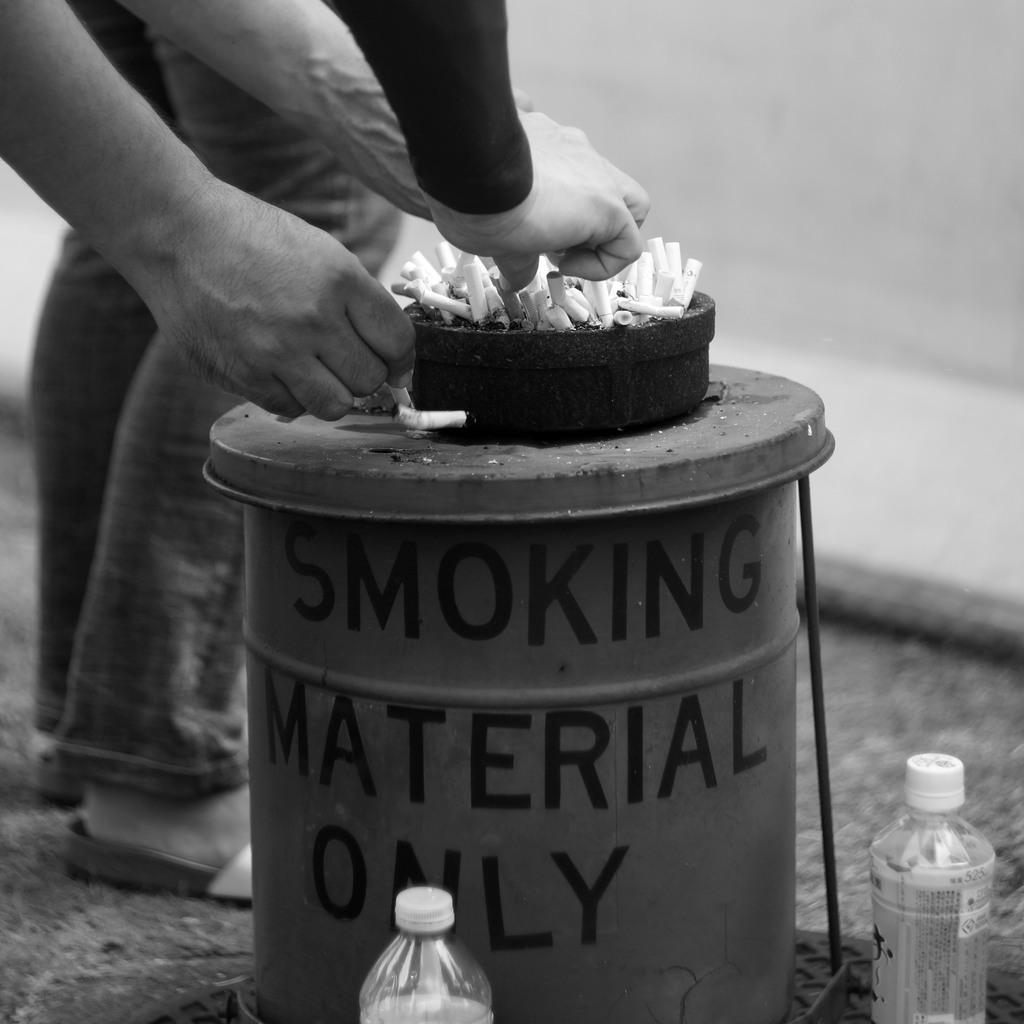What type of container is present in the image? There is a bin in the image. What other object related to waste disposal can be seen in the image? There is an ashtray in the image. Are there any people in the image? Yes, there are people in front of the bin and ashtray. Where is the toothbrush located in the image? There is no toothbrush present in the image. What discovery was made by the people in the image? The image does not depict a discovery or any related actions. 